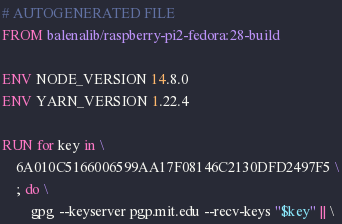Convert code to text. <code><loc_0><loc_0><loc_500><loc_500><_Dockerfile_># AUTOGENERATED FILE
FROM balenalib/raspberry-pi2-fedora:28-build

ENV NODE_VERSION 14.8.0
ENV YARN_VERSION 1.22.4

RUN for key in \
	6A010C5166006599AA17F08146C2130DFD2497F5 \
	; do \
		gpg --keyserver pgp.mit.edu --recv-keys "$key" || \</code> 